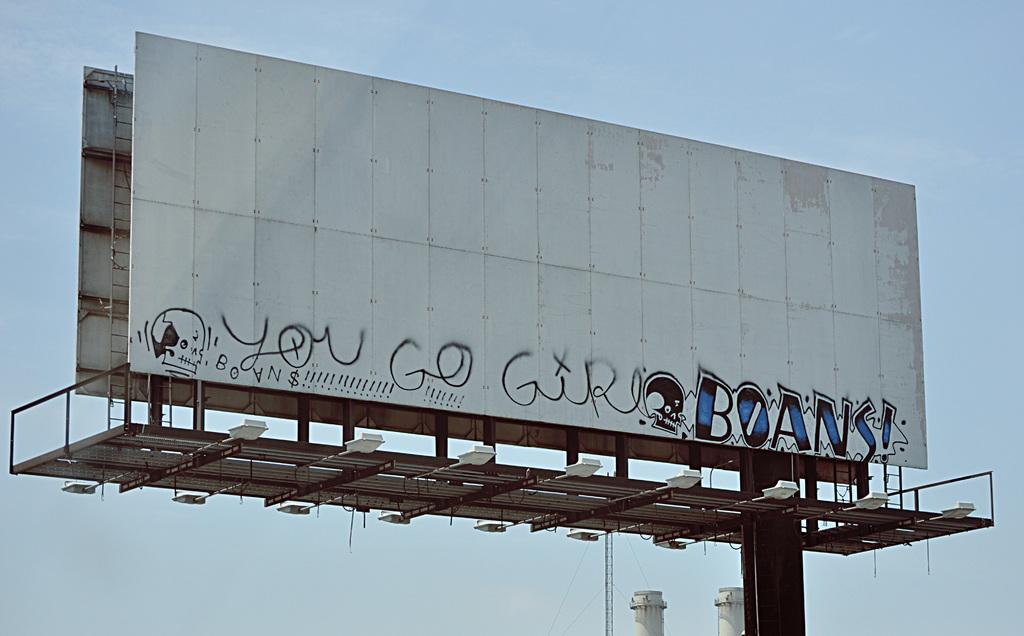<image>
Share a concise interpretation of the image provided. Graffiti on a white bill board has a skull and the writing, "you go girl" on it. 